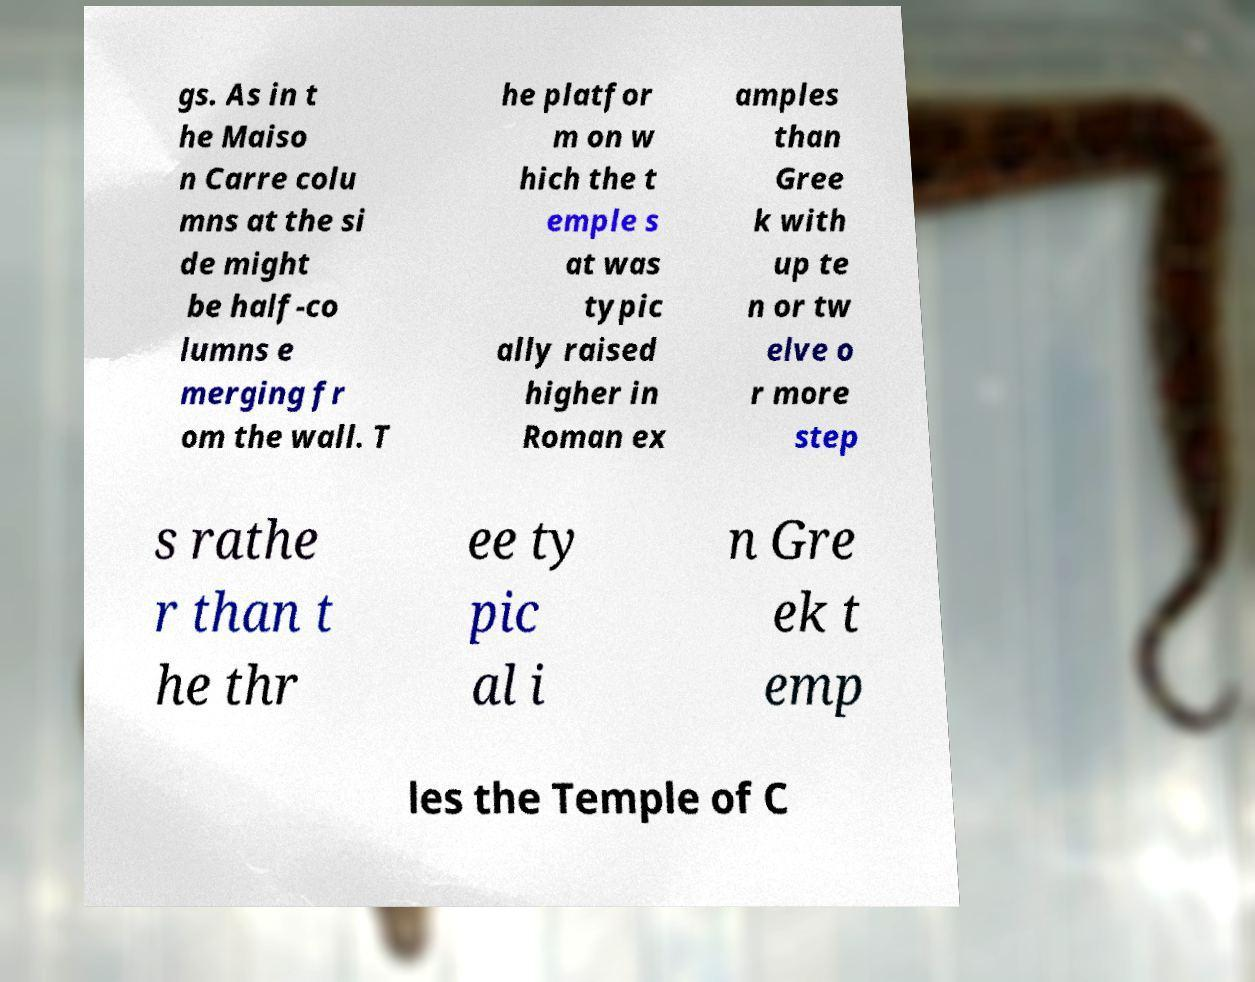Could you assist in decoding the text presented in this image and type it out clearly? gs. As in t he Maiso n Carre colu mns at the si de might be half-co lumns e merging fr om the wall. T he platfor m on w hich the t emple s at was typic ally raised higher in Roman ex amples than Gree k with up te n or tw elve o r more step s rathe r than t he thr ee ty pic al i n Gre ek t emp les the Temple of C 